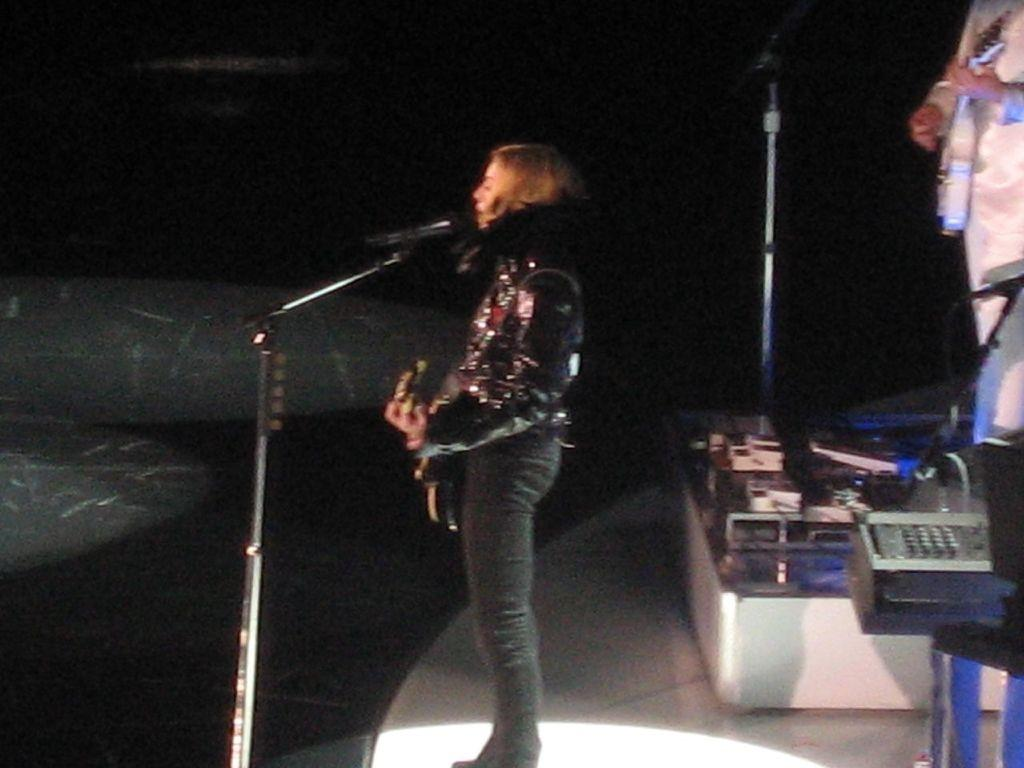What is the woman in the image doing? The woman is playing a guitar and singing. What is the woman wearing in the image? The woman is wearing a black shirt. What object is in front of the woman? There is a microphone in front of the woman. Can you describe the person in the background of the image? The person in the background is wearing a white dress and playing a guitar. How many spiders are crawling on the guitar in the image? There are no spiders present in the image; it features a woman playing a guitar and singing. What type of house is visible in the background of the image? There is no house visible in the background of the image; it features a woman playing a guitar and singing, with a person in the background wearing a white dress and playing a guitar as well. 